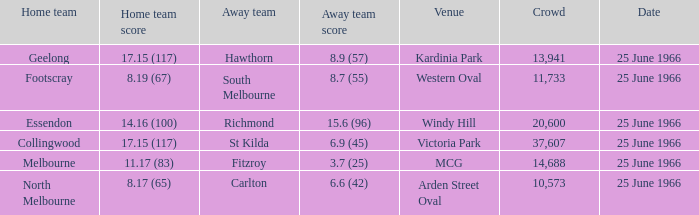How many people were present in the crowd when the home team scored 17.15 (117) in a match against hawthorn? 13941.0. 